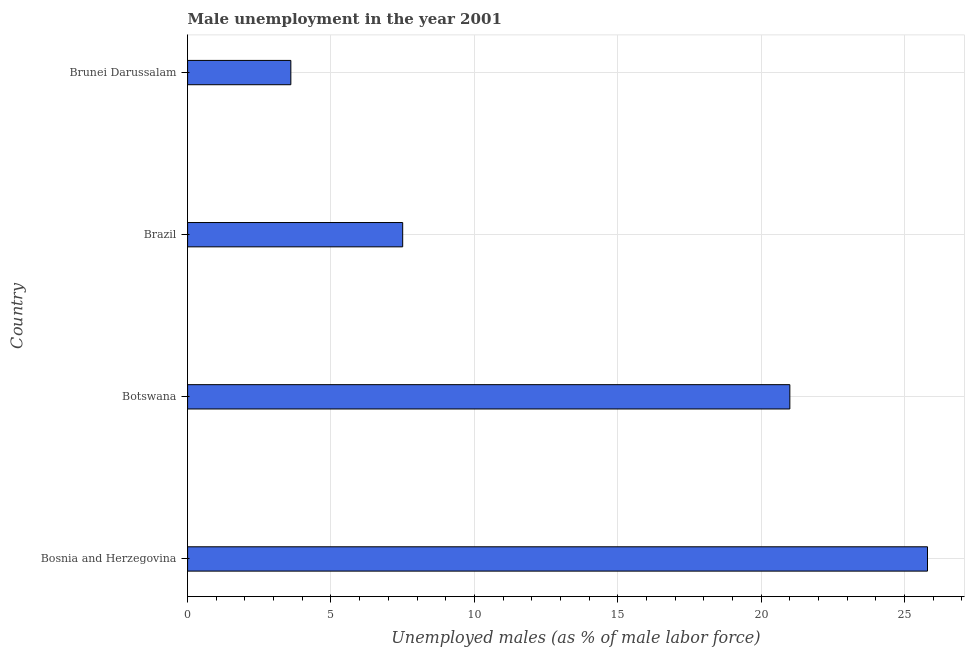What is the title of the graph?
Offer a very short reply. Male unemployment in the year 2001. What is the label or title of the X-axis?
Ensure brevity in your answer.  Unemployed males (as % of male labor force). What is the label or title of the Y-axis?
Provide a succinct answer. Country. What is the unemployed males population in Botswana?
Provide a succinct answer. 21. Across all countries, what is the maximum unemployed males population?
Ensure brevity in your answer.  25.8. Across all countries, what is the minimum unemployed males population?
Ensure brevity in your answer.  3.6. In which country was the unemployed males population maximum?
Your answer should be compact. Bosnia and Herzegovina. In which country was the unemployed males population minimum?
Offer a terse response. Brunei Darussalam. What is the sum of the unemployed males population?
Offer a very short reply. 57.9. What is the average unemployed males population per country?
Offer a very short reply. 14.47. What is the median unemployed males population?
Provide a short and direct response. 14.25. In how many countries, is the unemployed males population greater than 12 %?
Offer a very short reply. 2. What is the ratio of the unemployed males population in Bosnia and Herzegovina to that in Brunei Darussalam?
Offer a terse response. 7.17. Is the unemployed males population in Botswana less than that in Brazil?
Provide a succinct answer. No. Is the sum of the unemployed males population in Botswana and Brazil greater than the maximum unemployed males population across all countries?
Provide a succinct answer. Yes. What is the difference between the highest and the lowest unemployed males population?
Provide a short and direct response. 22.2. In how many countries, is the unemployed males population greater than the average unemployed males population taken over all countries?
Provide a succinct answer. 2. How many bars are there?
Provide a succinct answer. 4. What is the difference between two consecutive major ticks on the X-axis?
Give a very brief answer. 5. What is the Unemployed males (as % of male labor force) in Bosnia and Herzegovina?
Provide a succinct answer. 25.8. What is the Unemployed males (as % of male labor force) in Brazil?
Keep it short and to the point. 7.5. What is the Unemployed males (as % of male labor force) of Brunei Darussalam?
Give a very brief answer. 3.6. What is the difference between the Unemployed males (as % of male labor force) in Bosnia and Herzegovina and Botswana?
Your answer should be very brief. 4.8. What is the difference between the Unemployed males (as % of male labor force) in Bosnia and Herzegovina and Brunei Darussalam?
Your answer should be very brief. 22.2. What is the ratio of the Unemployed males (as % of male labor force) in Bosnia and Herzegovina to that in Botswana?
Ensure brevity in your answer.  1.23. What is the ratio of the Unemployed males (as % of male labor force) in Bosnia and Herzegovina to that in Brazil?
Your answer should be very brief. 3.44. What is the ratio of the Unemployed males (as % of male labor force) in Bosnia and Herzegovina to that in Brunei Darussalam?
Provide a succinct answer. 7.17. What is the ratio of the Unemployed males (as % of male labor force) in Botswana to that in Brazil?
Offer a very short reply. 2.8. What is the ratio of the Unemployed males (as % of male labor force) in Botswana to that in Brunei Darussalam?
Ensure brevity in your answer.  5.83. What is the ratio of the Unemployed males (as % of male labor force) in Brazil to that in Brunei Darussalam?
Provide a succinct answer. 2.08. 